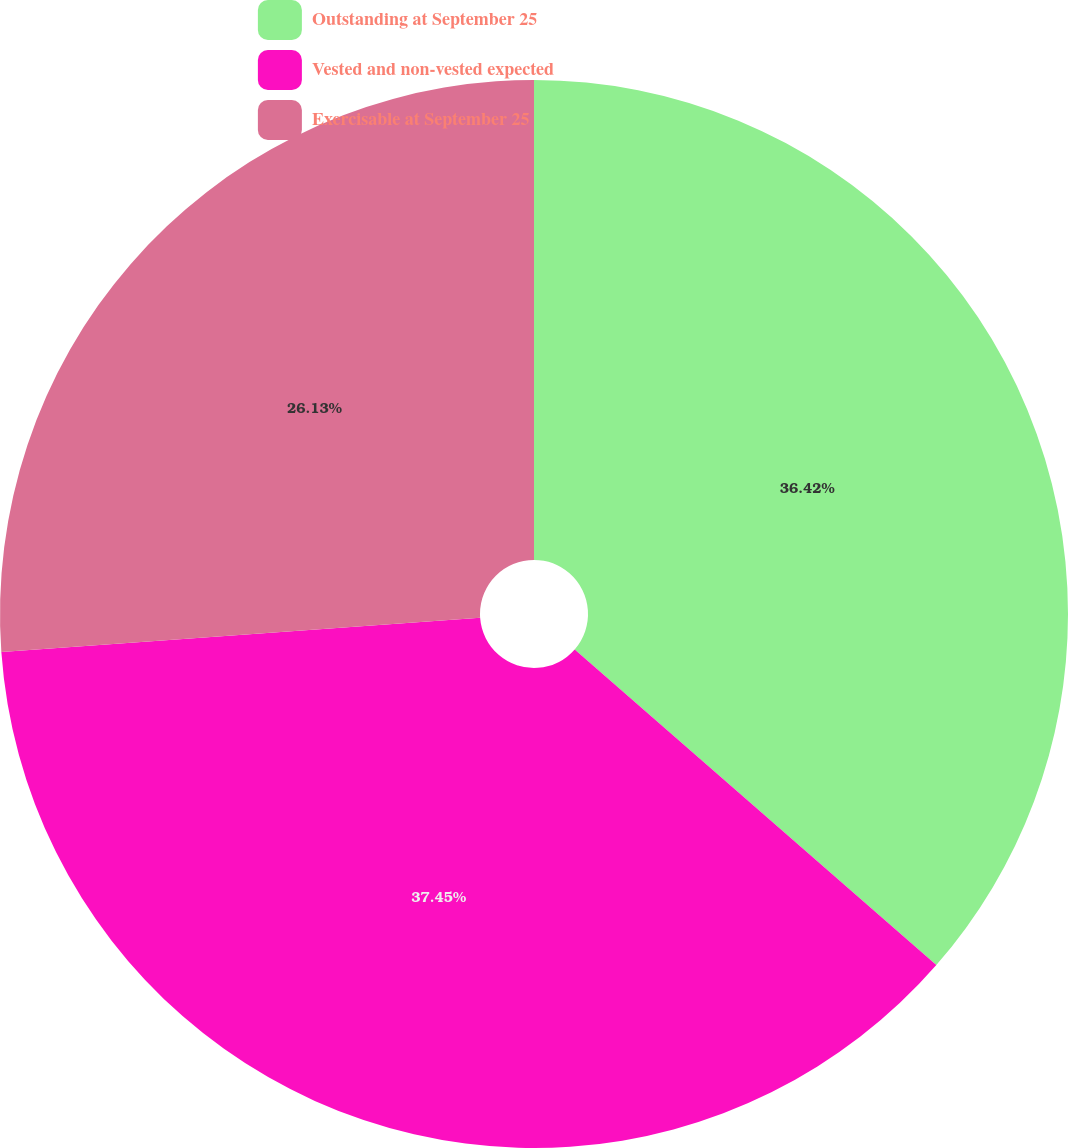Convert chart to OTSL. <chart><loc_0><loc_0><loc_500><loc_500><pie_chart><fcel>Outstanding at September 25<fcel>Vested and non-vested expected<fcel>Exercisable at September 25<nl><fcel>36.42%<fcel>37.45%<fcel>26.13%<nl></chart> 